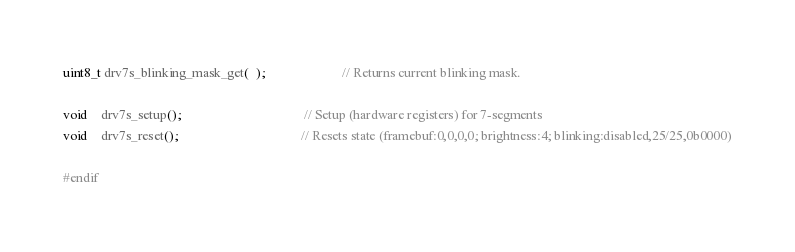<code> <loc_0><loc_0><loc_500><loc_500><_C_>uint8_t drv7s_blinking_mask_get(  );                       // Returns current blinking mask.

void    drv7s_setup();                                     // Setup (hardware registers) for 7-segments
void    drv7s_reset();                                     // Resets state (framebuf:0,0,0,0; brightness:4; blinking:disabled,25/25,0b0000)

#endif
</code> 